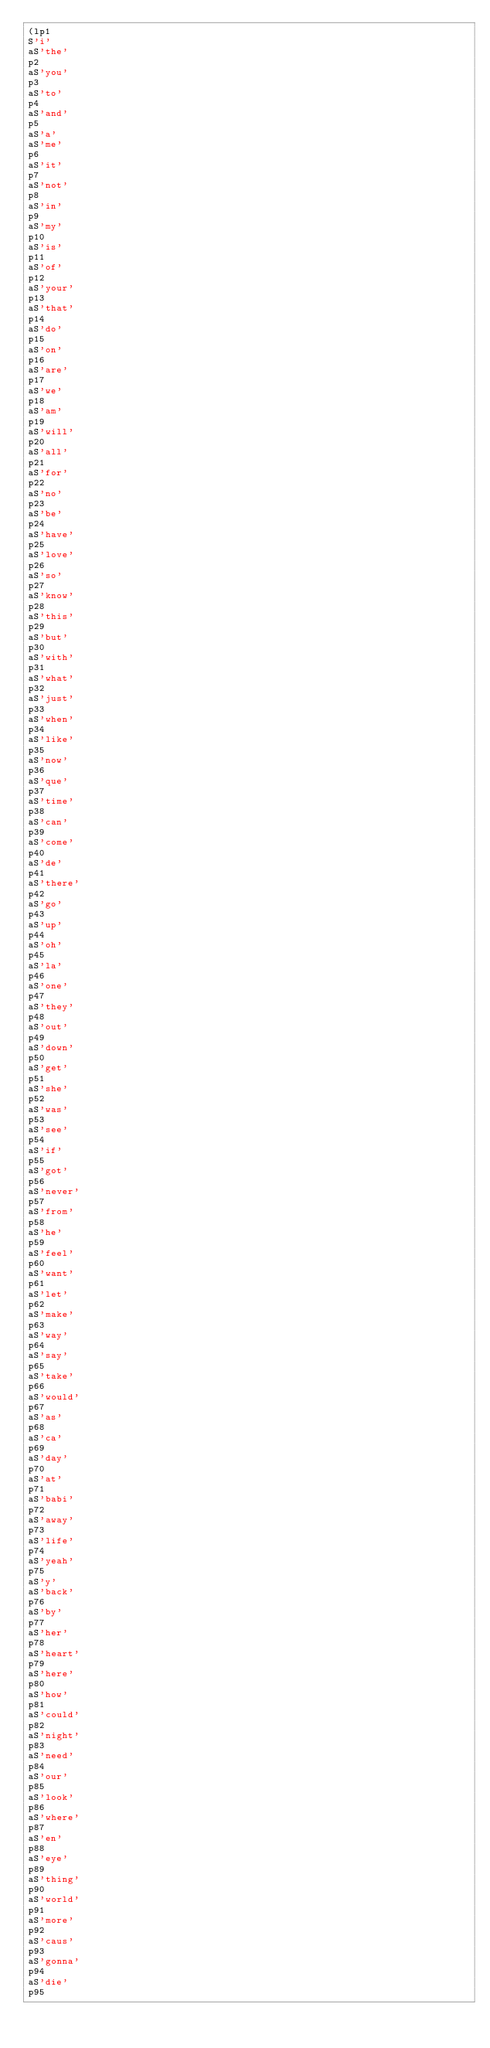Convert code to text. <code><loc_0><loc_0><loc_500><loc_500><_SQL_>(lp1
S'i'
aS'the'
p2
aS'you'
p3
aS'to'
p4
aS'and'
p5
aS'a'
aS'me'
p6
aS'it'
p7
aS'not'
p8
aS'in'
p9
aS'my'
p10
aS'is'
p11
aS'of'
p12
aS'your'
p13
aS'that'
p14
aS'do'
p15
aS'on'
p16
aS'are'
p17
aS'we'
p18
aS'am'
p19
aS'will'
p20
aS'all'
p21
aS'for'
p22
aS'no'
p23
aS'be'
p24
aS'have'
p25
aS'love'
p26
aS'so'
p27
aS'know'
p28
aS'this'
p29
aS'but'
p30
aS'with'
p31
aS'what'
p32
aS'just'
p33
aS'when'
p34
aS'like'
p35
aS'now'
p36
aS'que'
p37
aS'time'
p38
aS'can'
p39
aS'come'
p40
aS'de'
p41
aS'there'
p42
aS'go'
p43
aS'up'
p44
aS'oh'
p45
aS'la'
p46
aS'one'
p47
aS'they'
p48
aS'out'
p49
aS'down'
p50
aS'get'
p51
aS'she'
p52
aS'was'
p53
aS'see'
p54
aS'if'
p55
aS'got'
p56
aS'never'
p57
aS'from'
p58
aS'he'
p59
aS'feel'
p60
aS'want'
p61
aS'let'
p62
aS'make'
p63
aS'way'
p64
aS'say'
p65
aS'take'
p66
aS'would'
p67
aS'as'
p68
aS'ca'
p69
aS'day'
p70
aS'at'
p71
aS'babi'
p72
aS'away'
p73
aS'life'
p74
aS'yeah'
p75
aS'y'
aS'back'
p76
aS'by'
p77
aS'her'
p78
aS'heart'
p79
aS'here'
p80
aS'how'
p81
aS'could'
p82
aS'night'
p83
aS'need'
p84
aS'our'
p85
aS'look'
p86
aS'where'
p87
aS'en'
p88
aS'eye'
p89
aS'thing'
p90
aS'world'
p91
aS'more'
p92
aS'caus'
p93
aS'gonna'
p94
aS'die'
p95</code> 